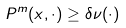<formula> <loc_0><loc_0><loc_500><loc_500>P ^ { m } ( x , \cdot ) \geq \delta \nu ( \cdot )</formula> 